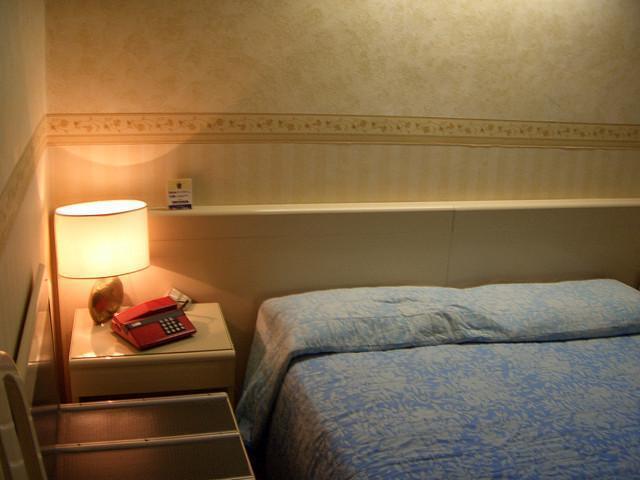How many chairs are in the picture?
Give a very brief answer. 1. 